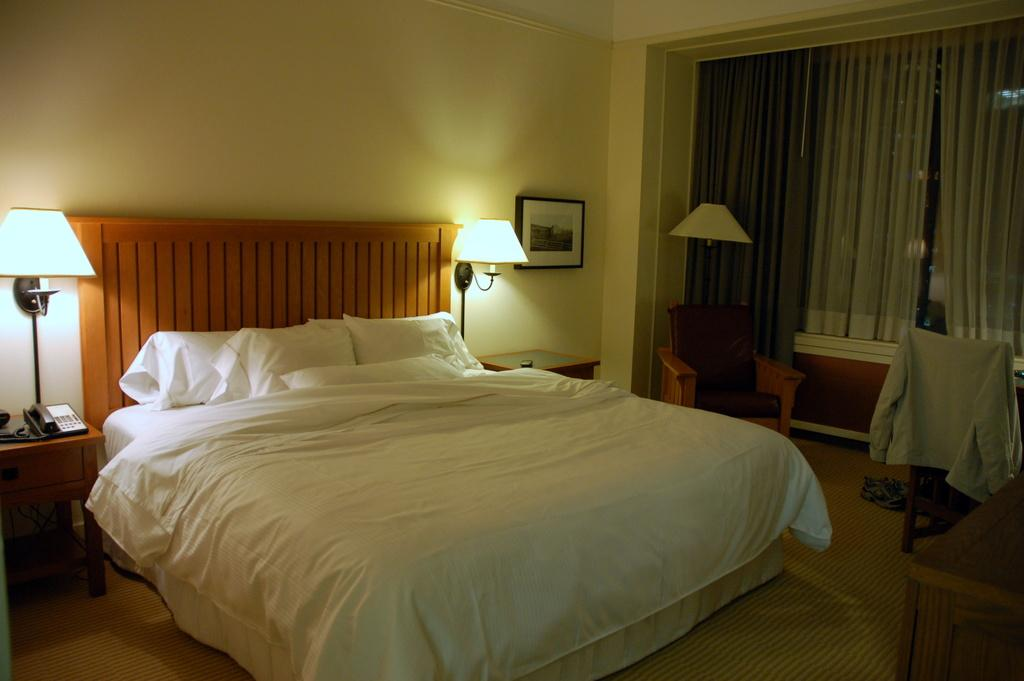What is the main object in the middle of the image? There is a bed in the middle of the image. What is placed on the bed? There are pillows on the bed. What can be seen on the left side of the image? There is a lamp on the left side of the image. What type of wall is on the right side of the image? There is a glass wall on the right side of the image. What is associated with the glass wall? There is there any window treatment? What type of lettuce can be seen growing in the image? There is no lettuce present in the image. Can you hear a bell ringing in the image? There is no bell present in the image, so it is not possible to hear it ringing. 